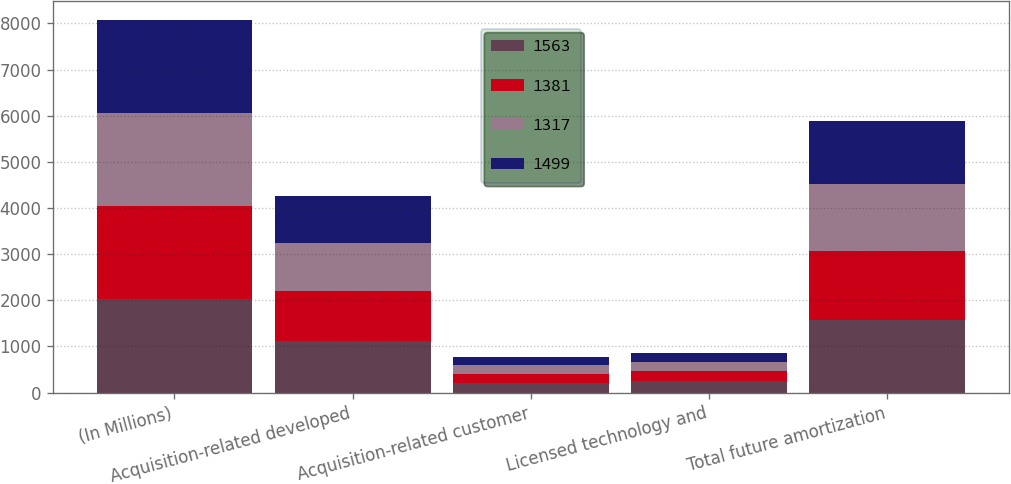<chart> <loc_0><loc_0><loc_500><loc_500><stacked_bar_chart><ecel><fcel>(In Millions)<fcel>Acquisition-related developed<fcel>Acquisition-related customer<fcel>Licensed technology and<fcel>Total future amortization<nl><fcel>1563<fcel>2019<fcel>1114<fcel>200<fcel>249<fcel>1563<nl><fcel>1381<fcel>2020<fcel>1082<fcel>199<fcel>218<fcel>1499<nl><fcel>1317<fcel>2021<fcel>1047<fcel>199<fcel>204<fcel>1450<nl><fcel>1499<fcel>2022<fcel>1008<fcel>177<fcel>196<fcel>1381<nl></chart> 